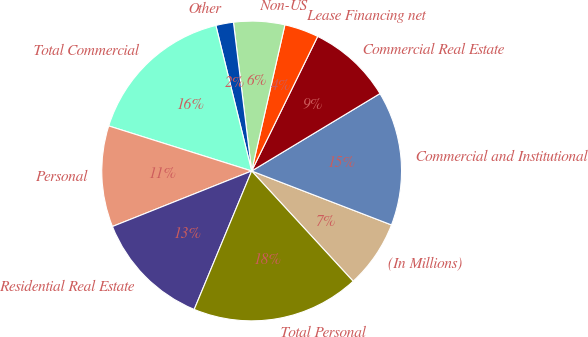Convert chart to OTSL. <chart><loc_0><loc_0><loc_500><loc_500><pie_chart><fcel>(In Millions)<fcel>Commercial and Institutional<fcel>Commercial Real Estate<fcel>Lease Financing net<fcel>Non-US<fcel>Other<fcel>Total Commercial<fcel>Personal<fcel>Residential Real Estate<fcel>Total Personal<nl><fcel>7.3%<fcel>14.5%<fcel>9.1%<fcel>3.7%<fcel>5.5%<fcel>1.9%<fcel>16.3%<fcel>10.9%<fcel>12.7%<fcel>18.1%<nl></chart> 